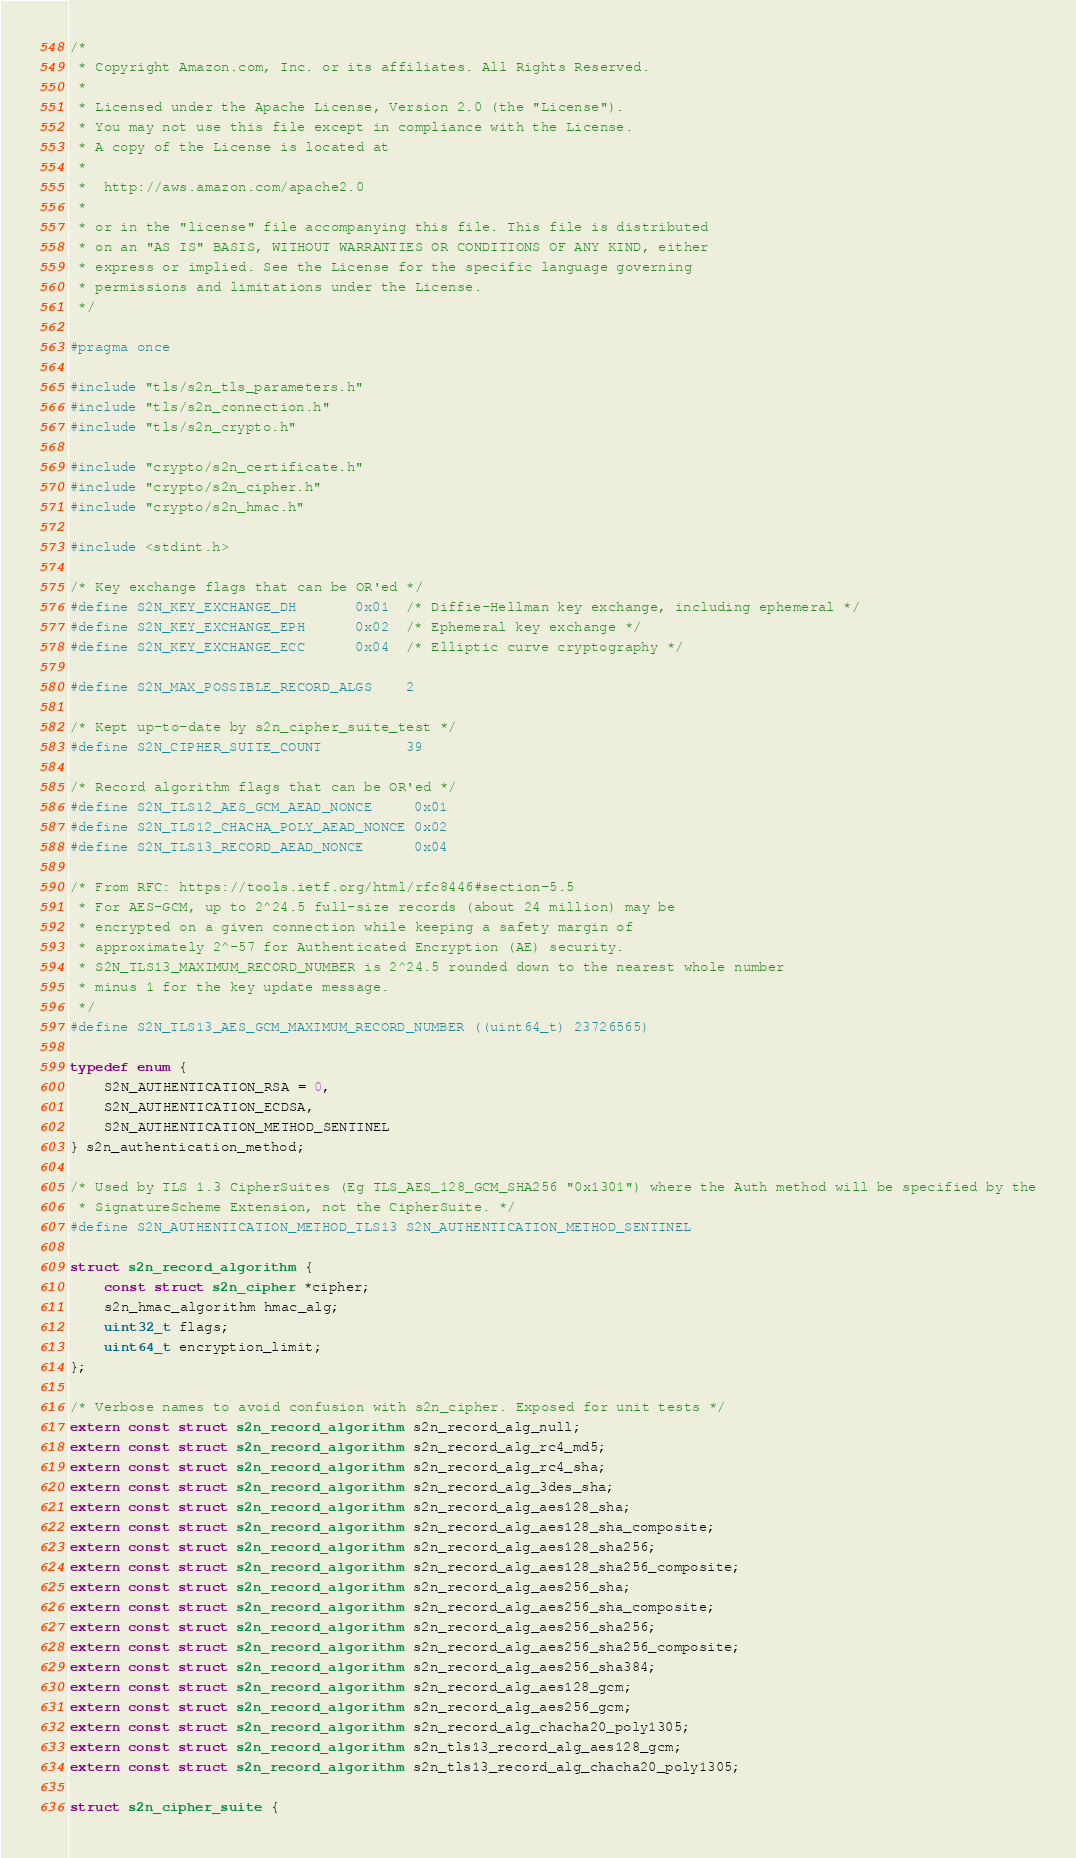Convert code to text. <code><loc_0><loc_0><loc_500><loc_500><_C_>/*
 * Copyright Amazon.com, Inc. or its affiliates. All Rights Reserved.
 *
 * Licensed under the Apache License, Version 2.0 (the "License").
 * You may not use this file except in compliance with the License.
 * A copy of the License is located at
 *
 *  http://aws.amazon.com/apache2.0
 *
 * or in the "license" file accompanying this file. This file is distributed
 * on an "AS IS" BASIS, WITHOUT WARRANTIES OR CONDITIONS OF ANY KIND, either
 * express or implied. See the License for the specific language governing
 * permissions and limitations under the License.
 */

#pragma once

#include "tls/s2n_tls_parameters.h"
#include "tls/s2n_connection.h"
#include "tls/s2n_crypto.h"

#include "crypto/s2n_certificate.h"
#include "crypto/s2n_cipher.h"
#include "crypto/s2n_hmac.h"

#include <stdint.h>

/* Key exchange flags that can be OR'ed */
#define S2N_KEY_EXCHANGE_DH       0x01  /* Diffie-Hellman key exchange, including ephemeral */
#define S2N_KEY_EXCHANGE_EPH      0x02  /* Ephemeral key exchange */
#define S2N_KEY_EXCHANGE_ECC      0x04  /* Elliptic curve cryptography */

#define S2N_MAX_POSSIBLE_RECORD_ALGS    2

/* Kept up-to-date by s2n_cipher_suite_test */
#define S2N_CIPHER_SUITE_COUNT          39

/* Record algorithm flags that can be OR'ed */
#define S2N_TLS12_AES_GCM_AEAD_NONCE     0x01
#define S2N_TLS12_CHACHA_POLY_AEAD_NONCE 0x02
#define S2N_TLS13_RECORD_AEAD_NONCE      0x04

/* From RFC: https://tools.ietf.org/html/rfc8446#section-5.5
 * For AES-GCM, up to 2^24.5 full-size records (about 24 million) may be
 * encrypted on a given connection while keeping a safety margin of
 * approximately 2^-57 for Authenticated Encryption (AE) security.
 * S2N_TLS13_MAXIMUM_RECORD_NUMBER is 2^24.5 rounded down to the nearest whole number
 * minus 1 for the key update message.
 */
#define S2N_TLS13_AES_GCM_MAXIMUM_RECORD_NUMBER ((uint64_t) 23726565)

typedef enum {
    S2N_AUTHENTICATION_RSA = 0,
    S2N_AUTHENTICATION_ECDSA,
    S2N_AUTHENTICATION_METHOD_SENTINEL
} s2n_authentication_method;

/* Used by TLS 1.3 CipherSuites (Eg TLS_AES_128_GCM_SHA256 "0x1301") where the Auth method will be specified by the
 * SignatureScheme Extension, not the CipherSuite. */
#define S2N_AUTHENTICATION_METHOD_TLS13 S2N_AUTHENTICATION_METHOD_SENTINEL

struct s2n_record_algorithm {
    const struct s2n_cipher *cipher;
    s2n_hmac_algorithm hmac_alg;
    uint32_t flags;
    uint64_t encryption_limit;
};

/* Verbose names to avoid confusion with s2n_cipher. Exposed for unit tests */
extern const struct s2n_record_algorithm s2n_record_alg_null;
extern const struct s2n_record_algorithm s2n_record_alg_rc4_md5;
extern const struct s2n_record_algorithm s2n_record_alg_rc4_sha;
extern const struct s2n_record_algorithm s2n_record_alg_3des_sha;
extern const struct s2n_record_algorithm s2n_record_alg_aes128_sha;
extern const struct s2n_record_algorithm s2n_record_alg_aes128_sha_composite;
extern const struct s2n_record_algorithm s2n_record_alg_aes128_sha256;
extern const struct s2n_record_algorithm s2n_record_alg_aes128_sha256_composite;
extern const struct s2n_record_algorithm s2n_record_alg_aes256_sha;
extern const struct s2n_record_algorithm s2n_record_alg_aes256_sha_composite;
extern const struct s2n_record_algorithm s2n_record_alg_aes256_sha256;
extern const struct s2n_record_algorithm s2n_record_alg_aes256_sha256_composite;
extern const struct s2n_record_algorithm s2n_record_alg_aes256_sha384;
extern const struct s2n_record_algorithm s2n_record_alg_aes128_gcm;
extern const struct s2n_record_algorithm s2n_record_alg_aes256_gcm;
extern const struct s2n_record_algorithm s2n_record_alg_chacha20_poly1305;
extern const struct s2n_record_algorithm s2n_tls13_record_alg_aes128_gcm;
extern const struct s2n_record_algorithm s2n_tls13_record_alg_chacha20_poly1305;

struct s2n_cipher_suite {</code> 